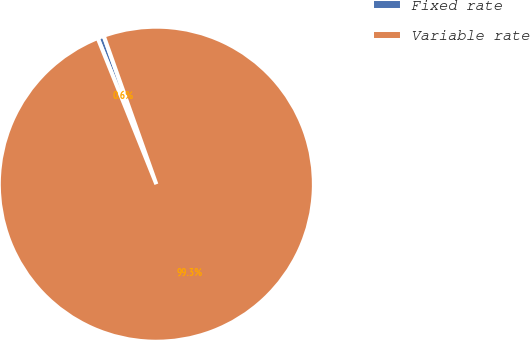Convert chart. <chart><loc_0><loc_0><loc_500><loc_500><pie_chart><fcel>Fixed rate<fcel>Variable rate<nl><fcel>0.65%<fcel>99.35%<nl></chart> 